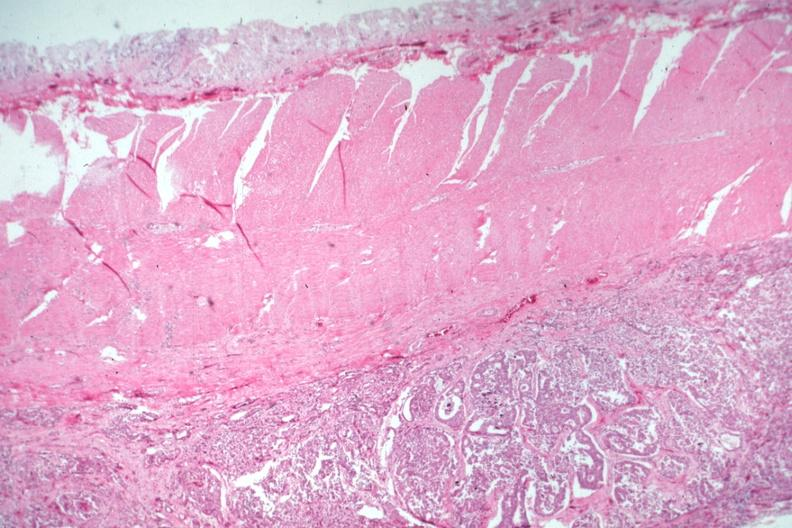s inflamed exocervix present?
Answer the question using a single word or phrase. No 